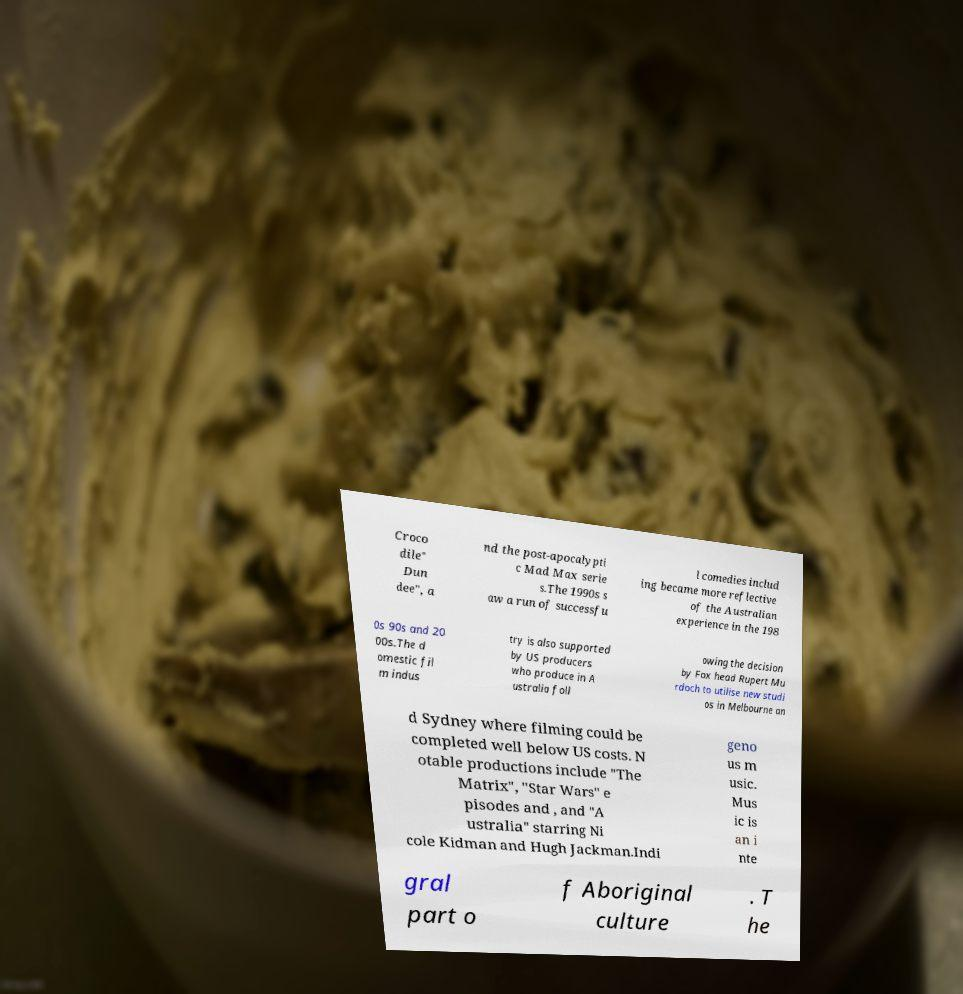I need the written content from this picture converted into text. Can you do that? Croco dile" Dun dee", a nd the post-apocalypti c Mad Max serie s.The 1990s s aw a run of successfu l comedies includ ing became more reflective of the Australian experience in the 198 0s 90s and 20 00s.The d omestic fil m indus try is also supported by US producers who produce in A ustralia foll owing the decision by Fox head Rupert Mu rdoch to utilise new studi os in Melbourne an d Sydney where filming could be completed well below US costs. N otable productions include "The Matrix", "Star Wars" e pisodes and , and "A ustralia" starring Ni cole Kidman and Hugh Jackman.Indi geno us m usic. Mus ic is an i nte gral part o f Aboriginal culture . T he 